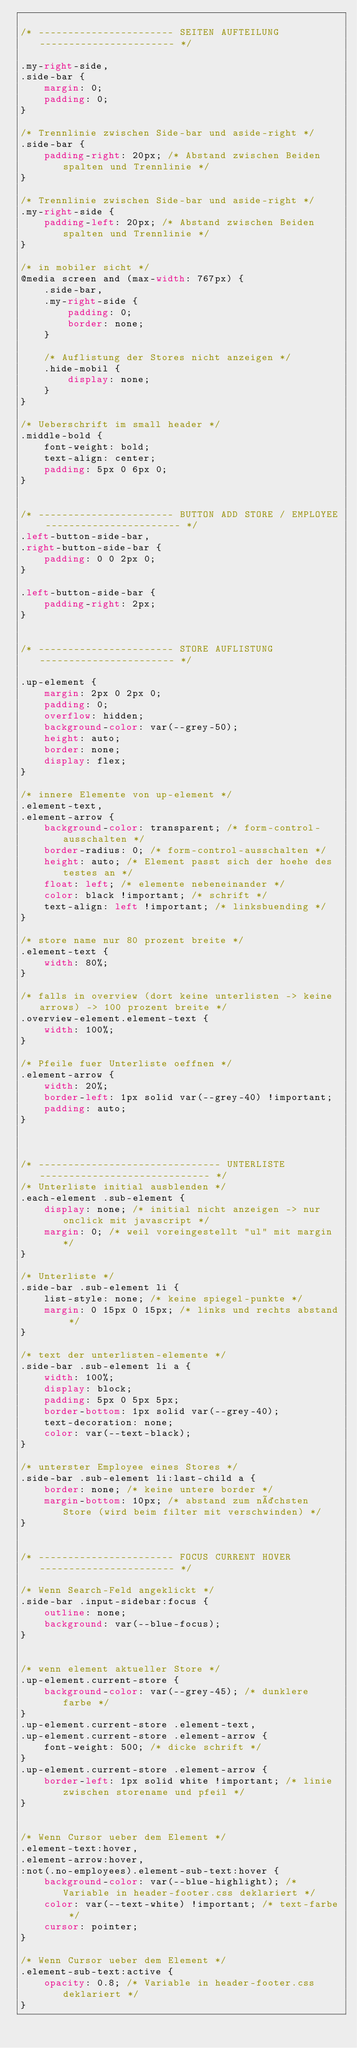Convert code to text. <code><loc_0><loc_0><loc_500><loc_500><_CSS_>
/* ----------------------- SEITEN AUFTEILUNG ----------------------- */

.my-right-side,
.side-bar {
    margin: 0;
    padding: 0;
}

/* Trennlinie zwischen Side-bar und aside-right */
.side-bar {
    padding-right: 20px; /* Abstand zwischen Beiden spalten und Trennlinie */
}

/* Trennlinie zwischen Side-bar und aside-right */
.my-right-side {
    padding-left: 20px; /* Abstand zwischen Beiden spalten und Trennlinie */
}

/* in mobiler sicht */
@media screen and (max-width: 767px) {
    .side-bar,
    .my-right-side {
        padding: 0;
        border: none;
    }

    /* Auflistung der Stores nicht anzeigen */
    .hide-mobil {
        display: none;
    }
}

/* Ueberschrift im small header */
.middle-bold {
    font-weight: bold;
    text-align: center;
    padding: 5px 0 6px 0;
}


/* ----------------------- BUTTON ADD STORE / EMPLOYEE ----------------------- */
.left-button-side-bar,
.right-button-side-bar {
    padding: 0 0 2px 0;
}

.left-button-side-bar {
    padding-right: 2px;
}


/* ----------------------- STORE AUFLISTUNG ----------------------- */

.up-element {
    margin: 2px 0 2px 0;
    padding: 0;
    overflow: hidden;
    background-color: var(--grey-50);
    height: auto;
    border: none;
    display: flex;
}

/* innere Elemente von up-element */
.element-text,
.element-arrow {
    background-color: transparent; /* form-control-ausschalten */
    border-radius: 0; /* form-control-ausschalten */
    height: auto; /* Element passt sich der hoehe des testes an */
    float: left; /* elemente nebeneinander */
    color: black !important; /* schrift */
    text-align: left !important; /* linksbuending */
}

/* store name nur 80 prozent breite */
.element-text {
    width: 80%;
}

/* falls in overview (dort keine unterlisten -> keine arrows) -> 100 prozent breite */
.overview-element.element-text {
    width: 100%;
}

/* Pfeile fuer Unterliste oeffnen */
.element-arrow {
    width: 20%;
    border-left: 1px solid var(--grey-40) !important;
    padding: auto;
}



/* ------------------------------- UNTERLISTE ----------------------------- */
/* Unterliste initial ausblenden */
.each-element .sub-element {
    display: none; /* initial nicht anzeigen -> nur onclick mit javascript */
    margin: 0; /* weil voreingestellt "ul" mit margin */
}

/* Unterliste */
.side-bar .sub-element li {
    list-style: none; /* keine spiegel-punkte */
    margin: 0 15px 0 15px; /* links und rechts abstand */
}

/* text der unterlisten-elemente */
.side-bar .sub-element li a {
    width: 100%;
    display: block;
    padding: 5px 0 5px 5px;
    border-bottom: 1px solid var(--grey-40);
    text-decoration: none;
    color: var(--text-black);
}

/* unterster Employee eines Stores */
.side-bar .sub-element li:last-child a {
    border: none; /* keine untere border */
    margin-bottom: 10px; /* abstand zum nächsten Store (wird beim filter mit verschwinden) */
}


/* ----------------------- FOCUS CURRENT HOVER ----------------------- */

/* Wenn Search-Feld angeklickt */
.side-bar .input-sidebar:focus {
    outline: none;
    background: var(--blue-focus);
}


/* wenn element aktueller Store */
.up-element.current-store {
    background-color: var(--grey-45); /* dunklere farbe */
}
.up-element.current-store .element-text,
.up-element.current-store .element-arrow {
    font-weight: 500; /* dicke schrift */
}
.up-element.current-store .element-arrow {
    border-left: 1px solid white !important; /* linie zwischen storename und pfeil */
}


/* Wenn Cursor ueber dem Element */
.element-text:hover,
.element-arrow:hover,
:not(.no-employees).element-sub-text:hover {
    background-color: var(--blue-highlight); /* Variable in header-footer.css deklariert */
    color: var(--text-white) !important; /* text-farbe */
    cursor: pointer;
}

/* Wenn Cursor ueber dem Element */
.element-sub-text:active {
    opacity: 0.8; /* Variable in header-footer.css deklariert */
}</code> 